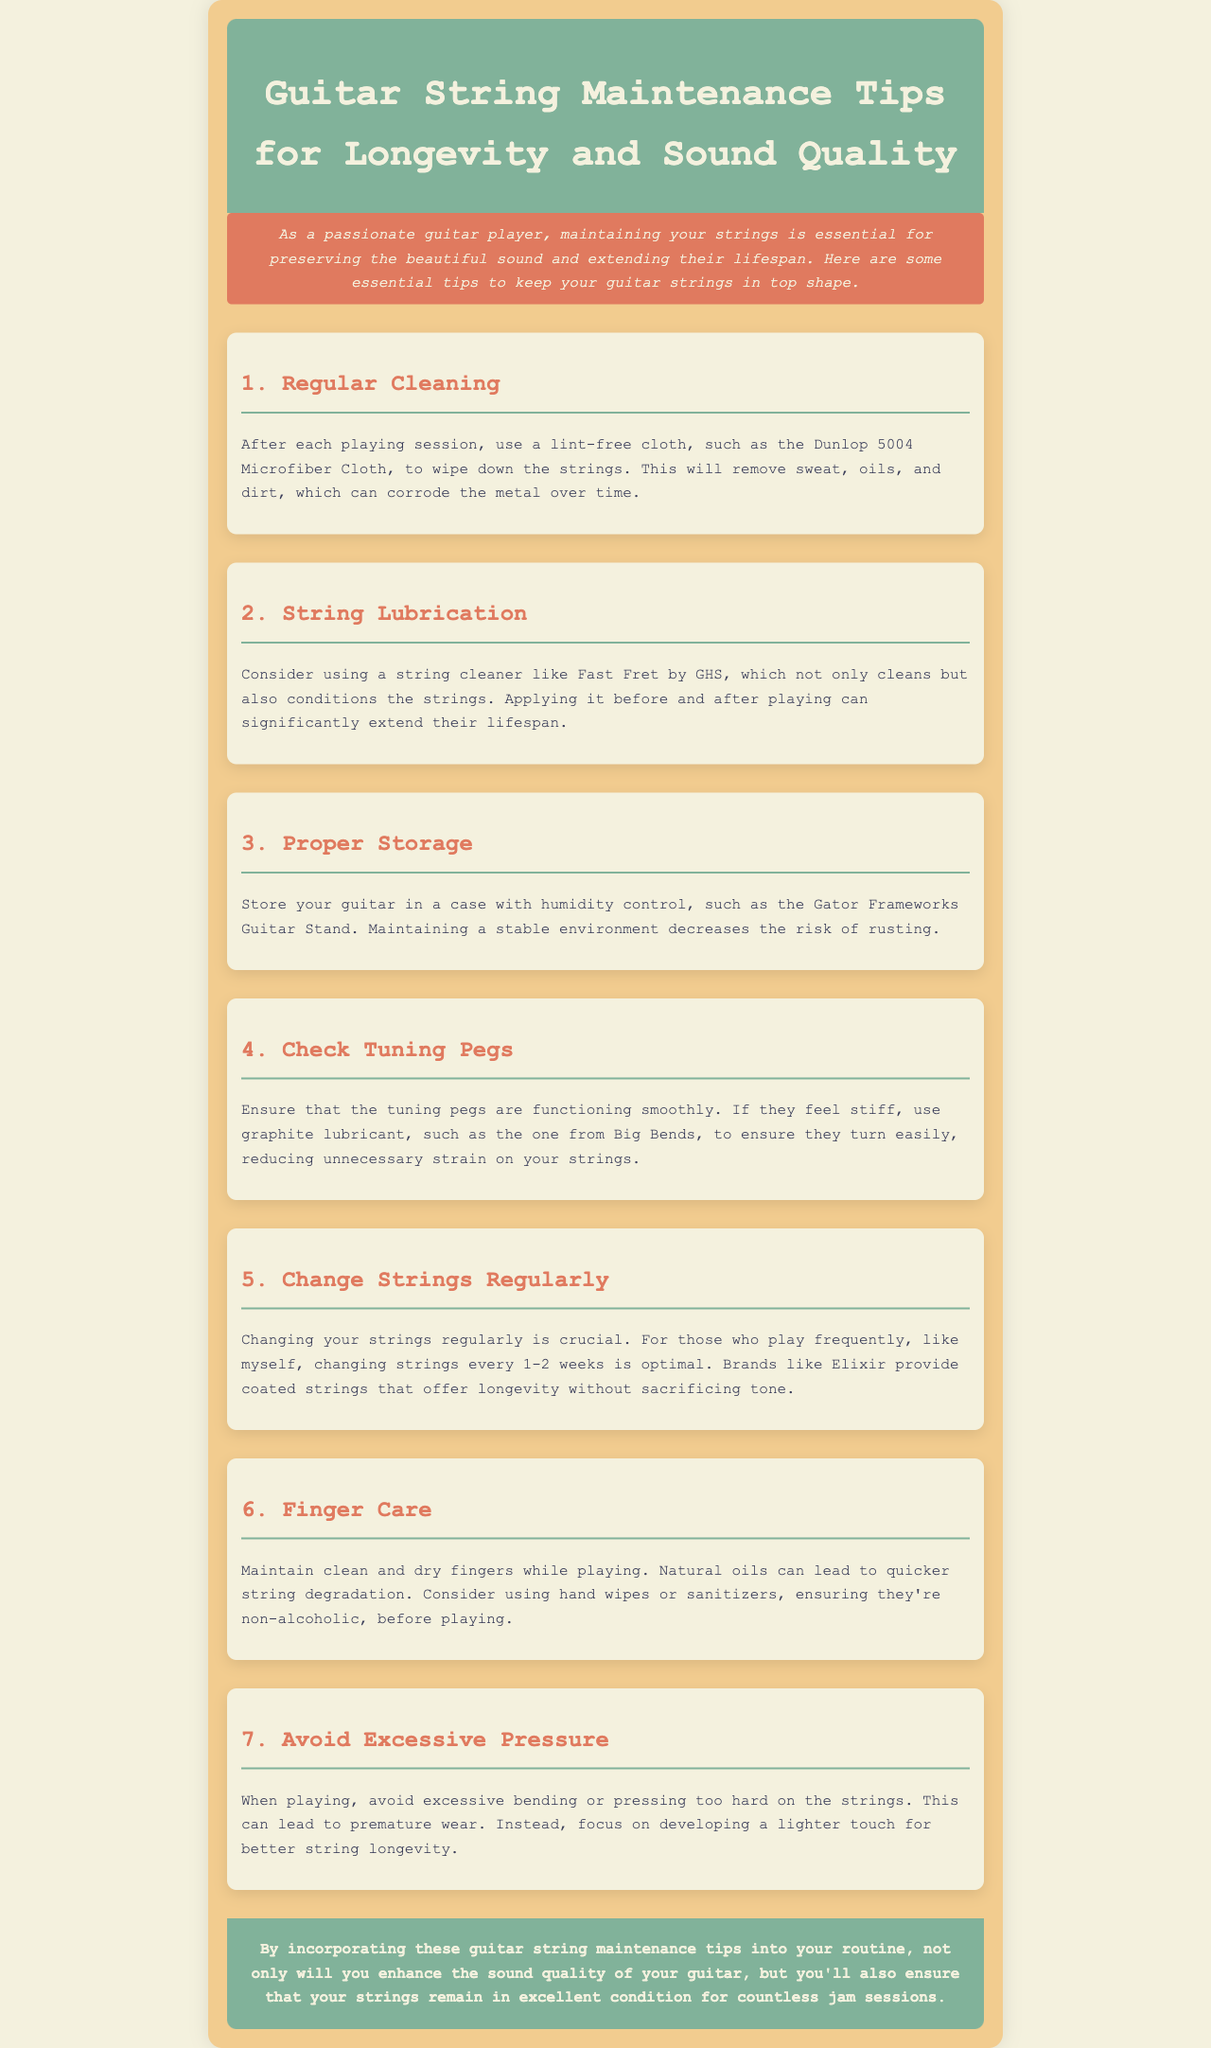What is the title of the newsletter? The title is displayed in the header of the document.
Answer: Guitar String Maintenance Tips for Longevity and Sound Quality How often should you change strings if you play frequently? The document recommends a specific frequency for changing strings based on playing frequency.
Answer: Every 1-2 weeks Which cloth is recommended for cleaning strings? The document mentions a specific product for cleaning strings after playing sessions.
Answer: Dunlop 5004 Microfiber Cloth What is one method to maintain finger condition while playing? The document advises on how to maintain finger condition to protect strings.
Answer: Use hand wipes What brand provides coated strings for longevity? The document mentions a specific brand known for its coated strings.
Answer: Elixir Why is proper storage important for guitar strings? The document discusses the importance of a stable environment in preventing degradation.
Answer: Decreases the risk of rusting What should be checked to ensure proper functioning of guitar strings? The text suggests an action concerning the mechanical components related to the strings.
Answer: Tuning pegs What product is suggested for lubricating tuning pegs? The document refers to a specific product for lubricating tuning pegs.
Answer: Big Bends 